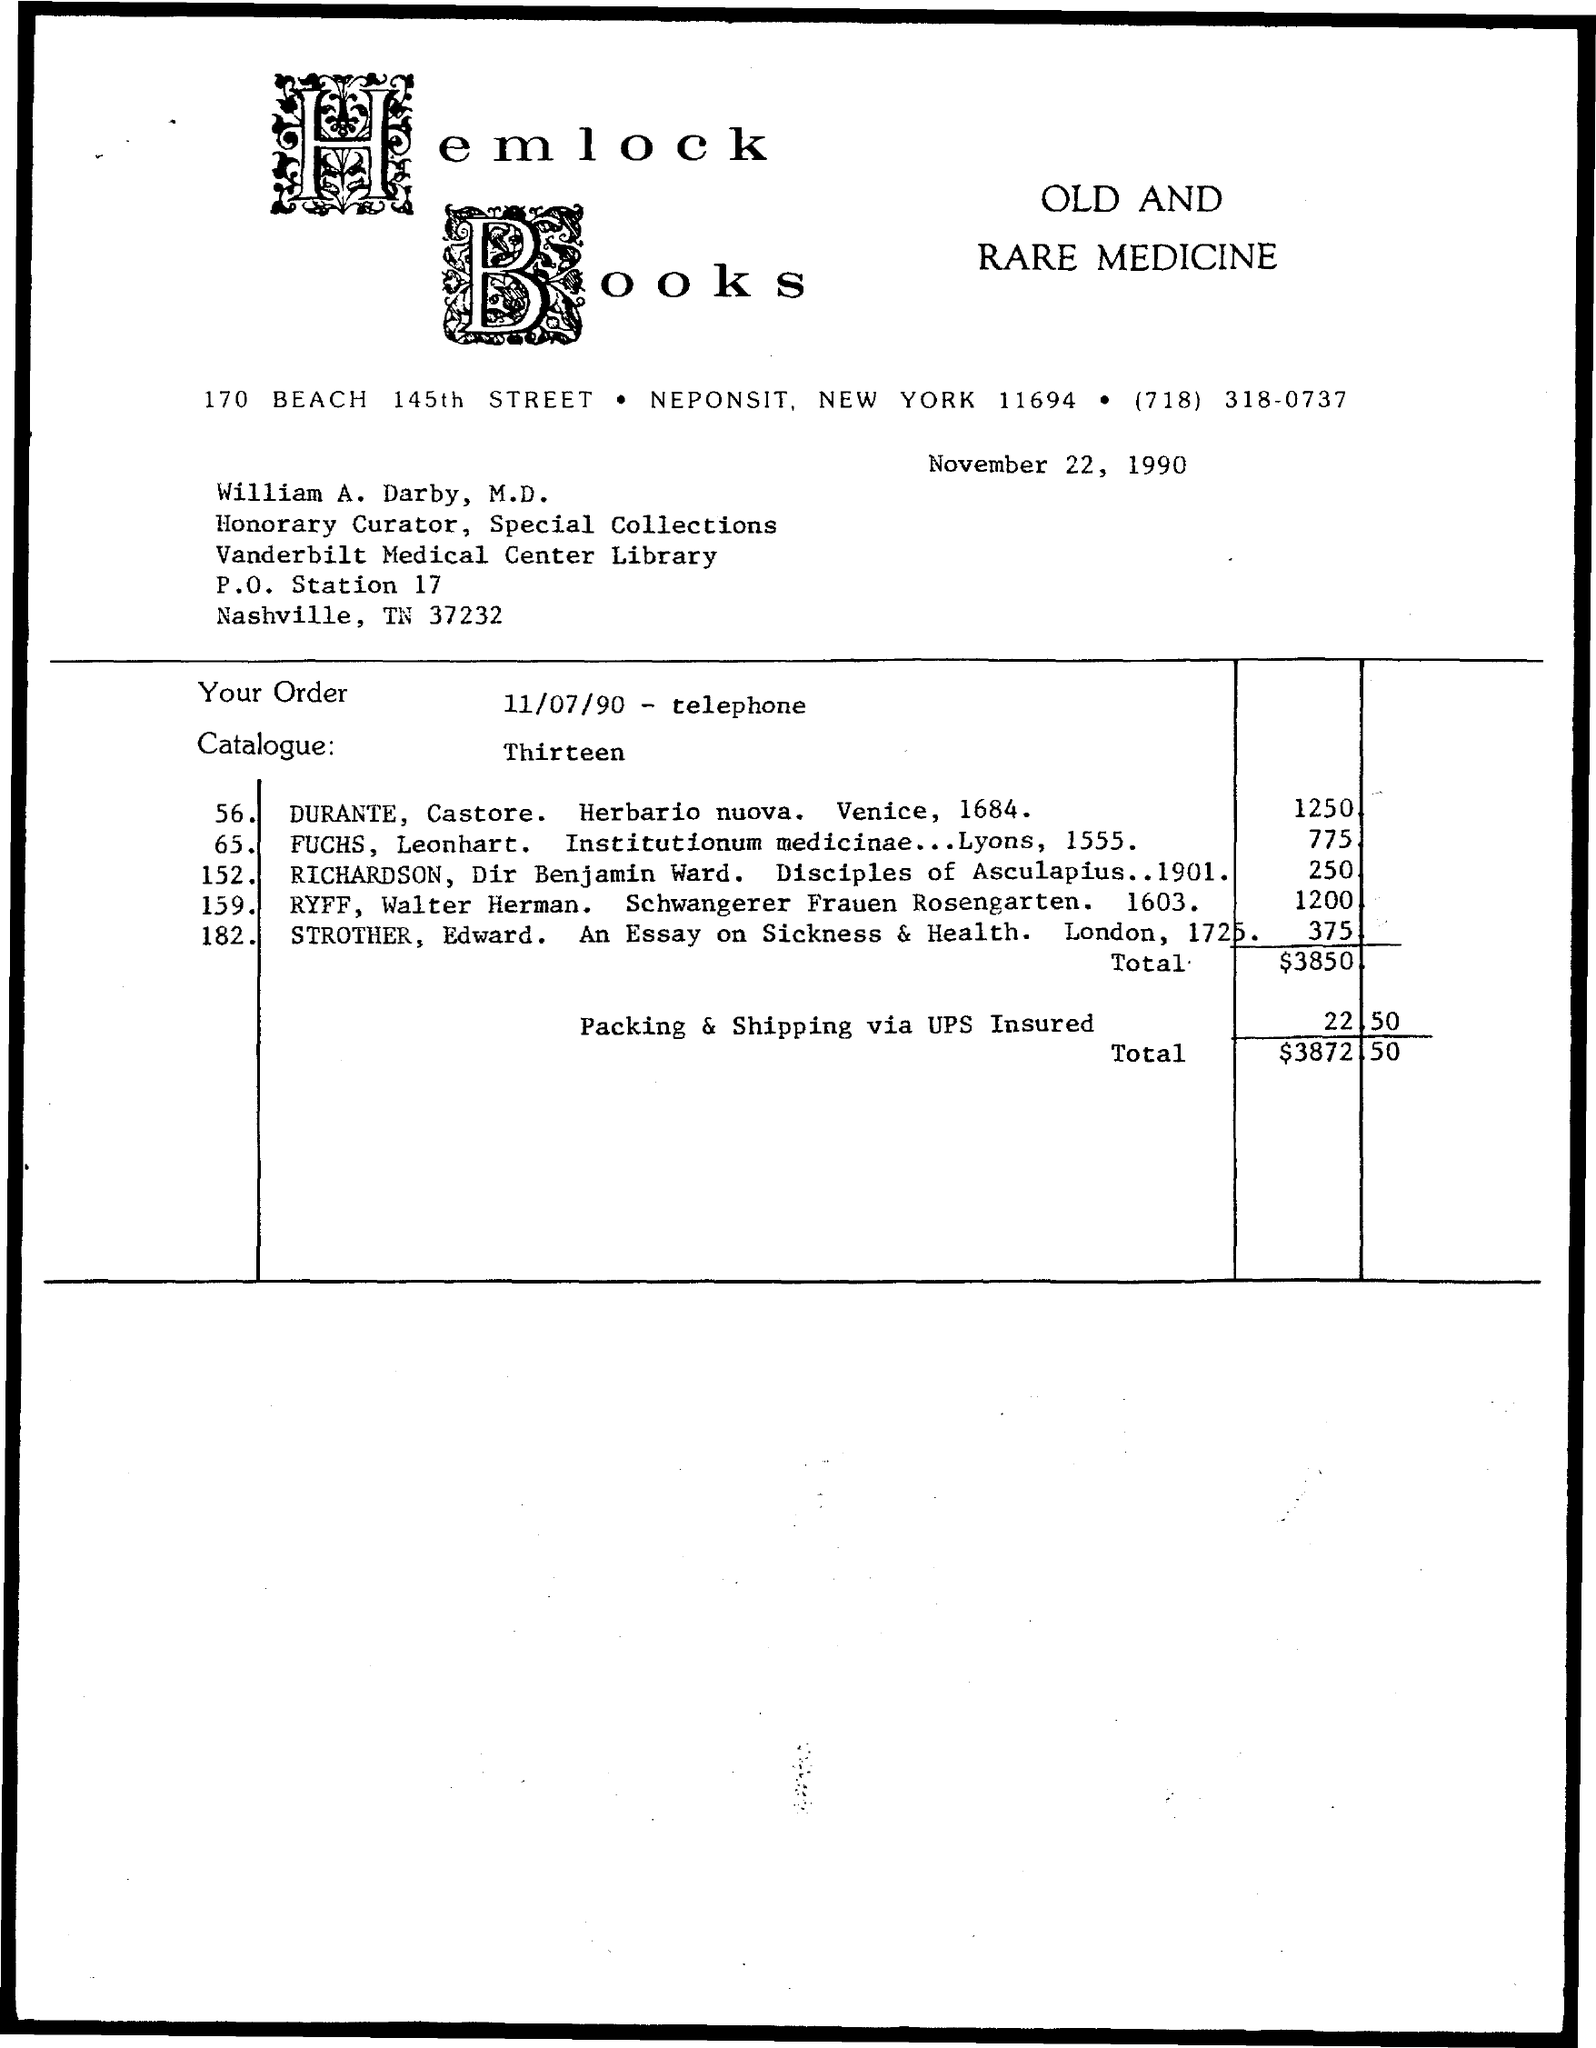What is the total amount mentioned in the given page ?
Provide a short and direct response. $ 3872.50. What is the amount for packing & shipping via ups insured ?
Offer a very short reply. 22.50. 